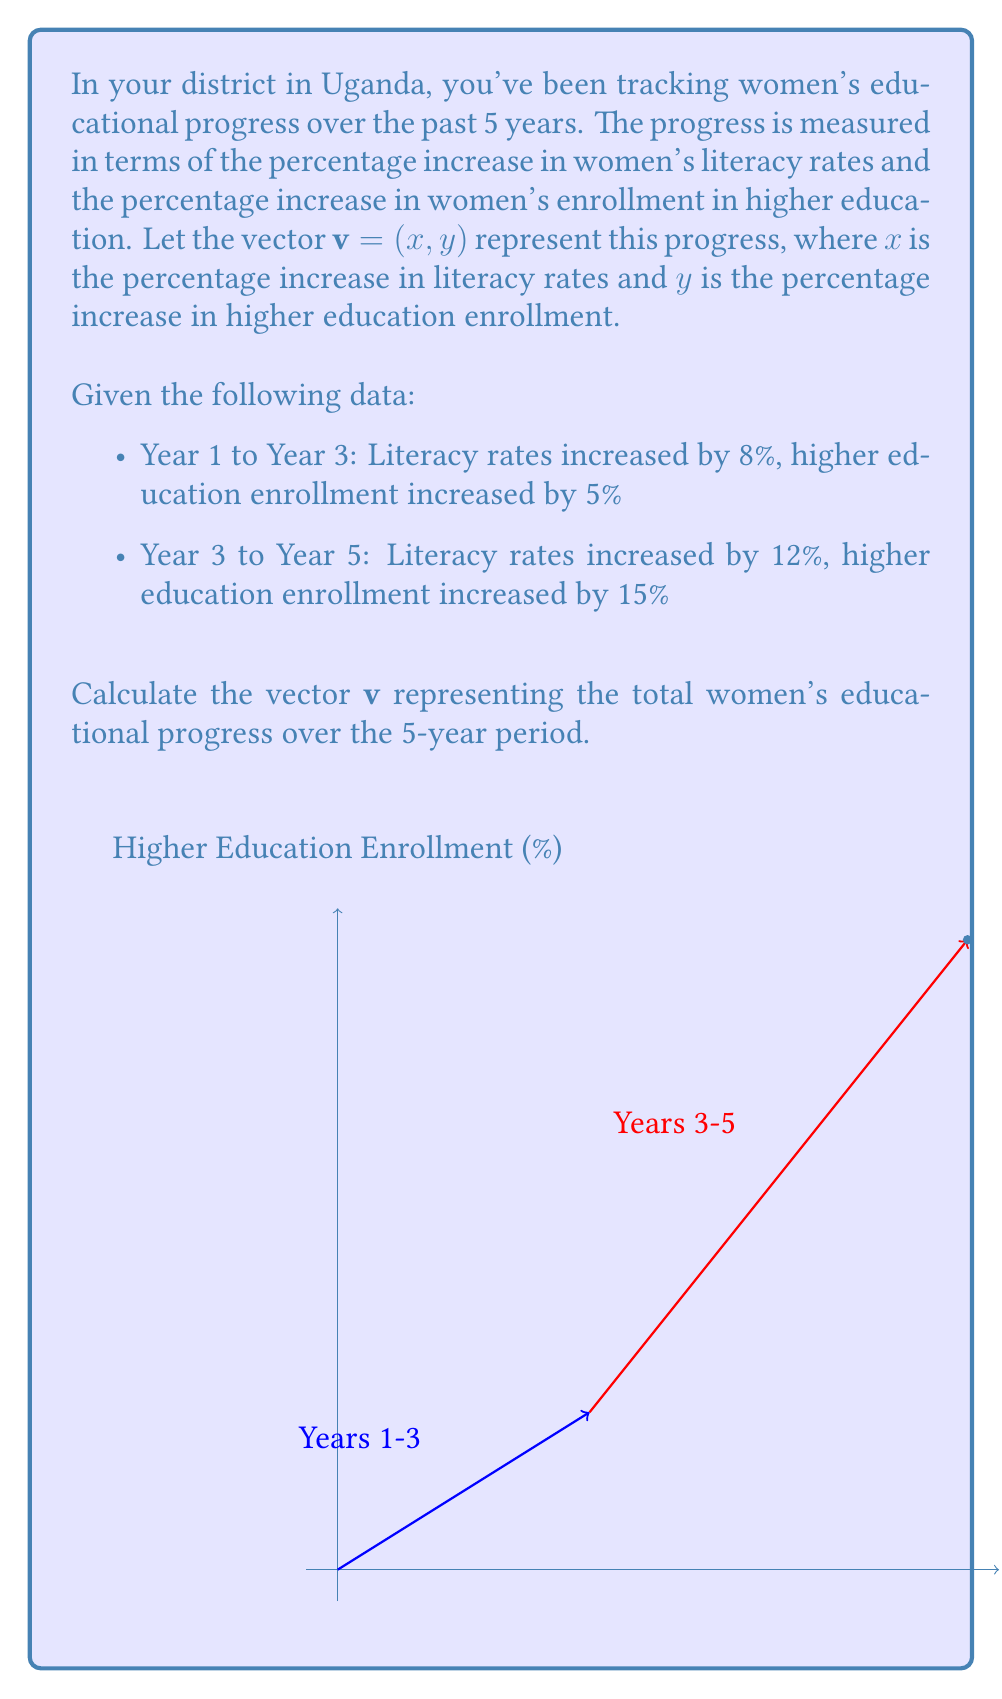What is the answer to this math problem? To solve this problem, we need to add the vectors representing the progress in each time period:

1. For Years 1-3:
   $\mathbf{v}_1 = (8, 5)$

2. For Years 3-5:
   $\mathbf{v}_2 = (12, 15)$

3. The total progress vector $\mathbf{v}$ is the sum of these two vectors:
   $\mathbf{v} = \mathbf{v}_1 + \mathbf{v}_2$

4. To add vectors, we add their corresponding components:
   $\mathbf{v} = (8 + 12, 5 + 15)$

5. Simplifying:
   $\mathbf{v} = (20, 20)$

Therefore, the vector representing the total women's educational progress over the 5-year period is $\mathbf{v} = (20, 20)$, indicating a 20% increase in literacy rates and a 20% increase in higher education enrollment.
Answer: $\mathbf{v} = (20, 20)$ 